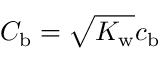<formula> <loc_0><loc_0><loc_500><loc_500>{ C _ { b } = \sqrt { K _ { w } } c _ { b } }</formula> 